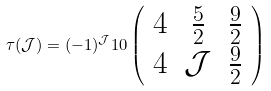<formula> <loc_0><loc_0><loc_500><loc_500>\tau ( \mathcal { J } ) = ( - 1 ) ^ { \mathcal { J } } 1 0 \left ( \begin{array} { c c c } 4 & \frac { 5 } { 2 } & \frac { 9 } { 2 } \\ 4 & \mathcal { J } & \frac { 9 } { 2 } \end{array} \right )</formula> 